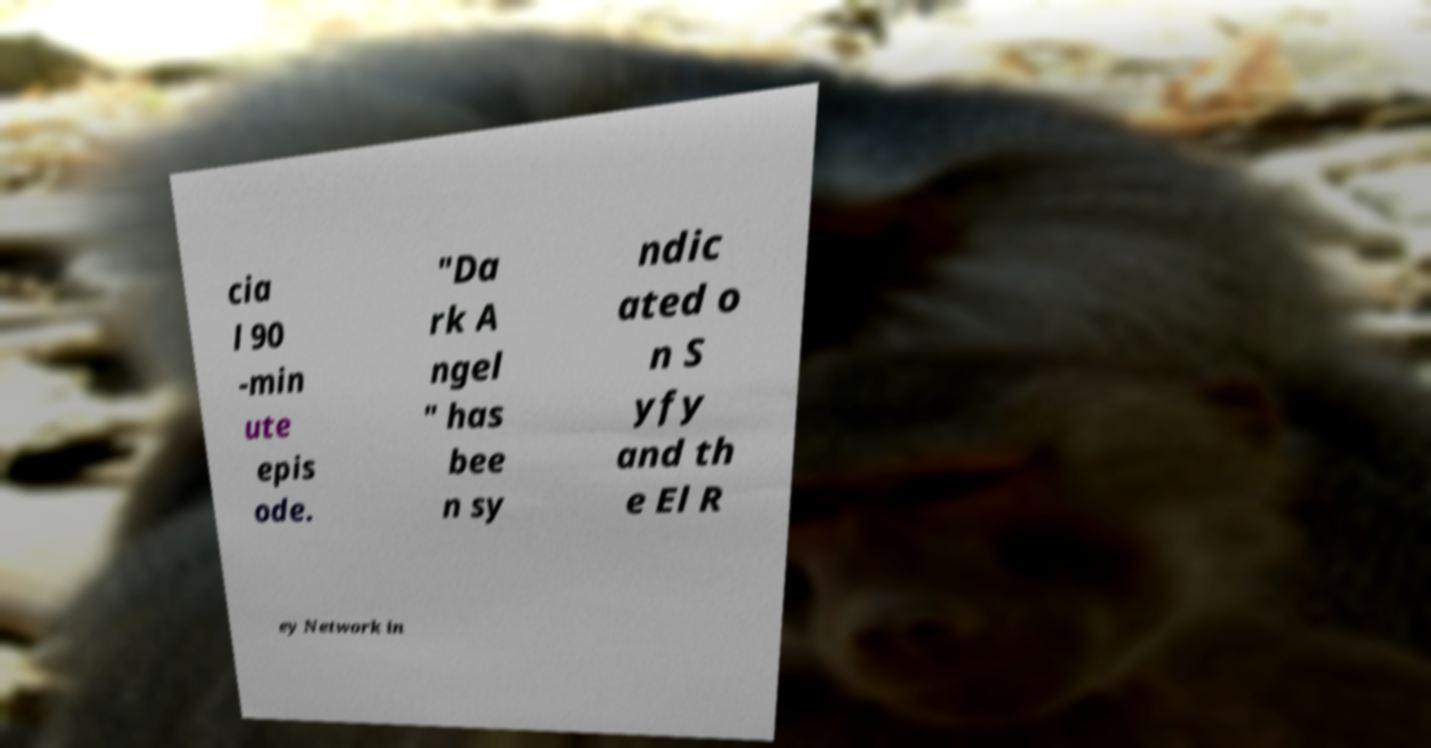Please read and relay the text visible in this image. What does it say? cia l 90 -min ute epis ode. "Da rk A ngel " has bee n sy ndic ated o n S yfy and th e El R ey Network in 